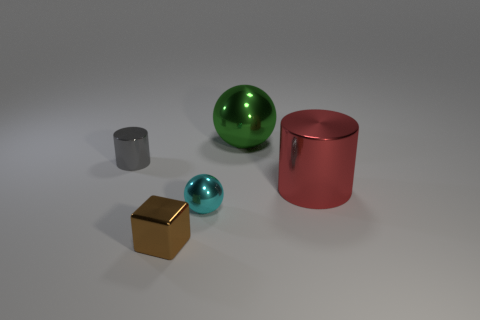Add 2 small metallic cylinders. How many objects exist? 7 Subtract all cubes. How many objects are left? 4 Subtract all big metallic spheres. Subtract all big things. How many objects are left? 2 Add 2 tiny cyan metal things. How many tiny cyan metal things are left? 3 Add 2 small brown objects. How many small brown objects exist? 3 Subtract 1 green spheres. How many objects are left? 4 